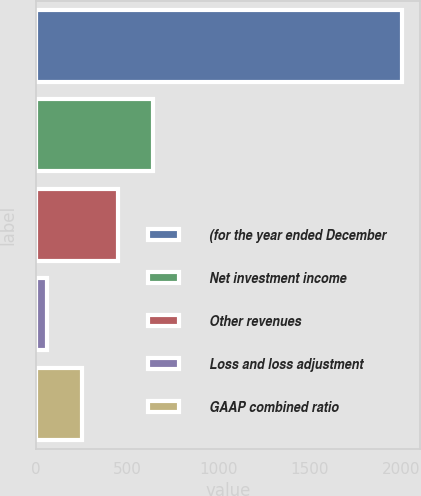Convert chart to OTSL. <chart><loc_0><loc_0><loc_500><loc_500><bar_chart><fcel>(for the year ended December<fcel>Net investment income<fcel>Other revenues<fcel>Loss and loss adjustment<fcel>GAAP combined ratio<nl><fcel>2004<fcel>642.01<fcel>447.44<fcel>58.3<fcel>252.87<nl></chart> 